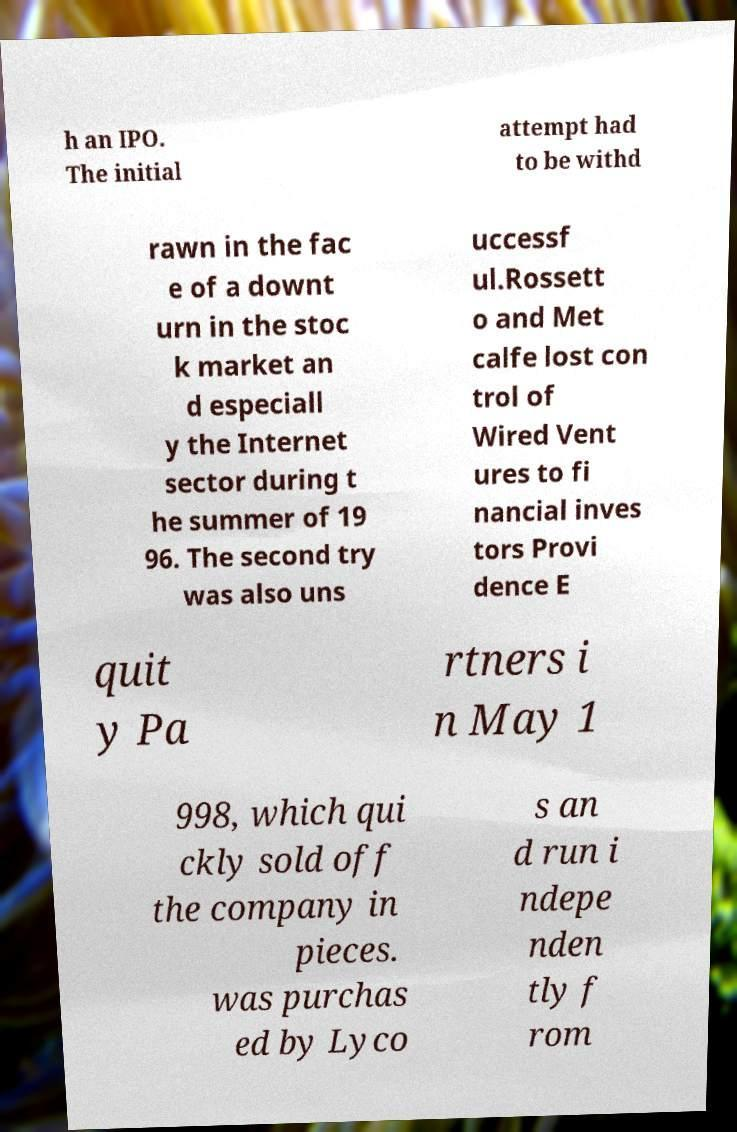Could you assist in decoding the text presented in this image and type it out clearly? h an IPO. The initial attempt had to be withd rawn in the fac e of a downt urn in the stoc k market an d especiall y the Internet sector during t he summer of 19 96. The second try was also uns uccessf ul.Rossett o and Met calfe lost con trol of Wired Vent ures to fi nancial inves tors Provi dence E quit y Pa rtners i n May 1 998, which qui ckly sold off the company in pieces. was purchas ed by Lyco s an d run i ndepe nden tly f rom 